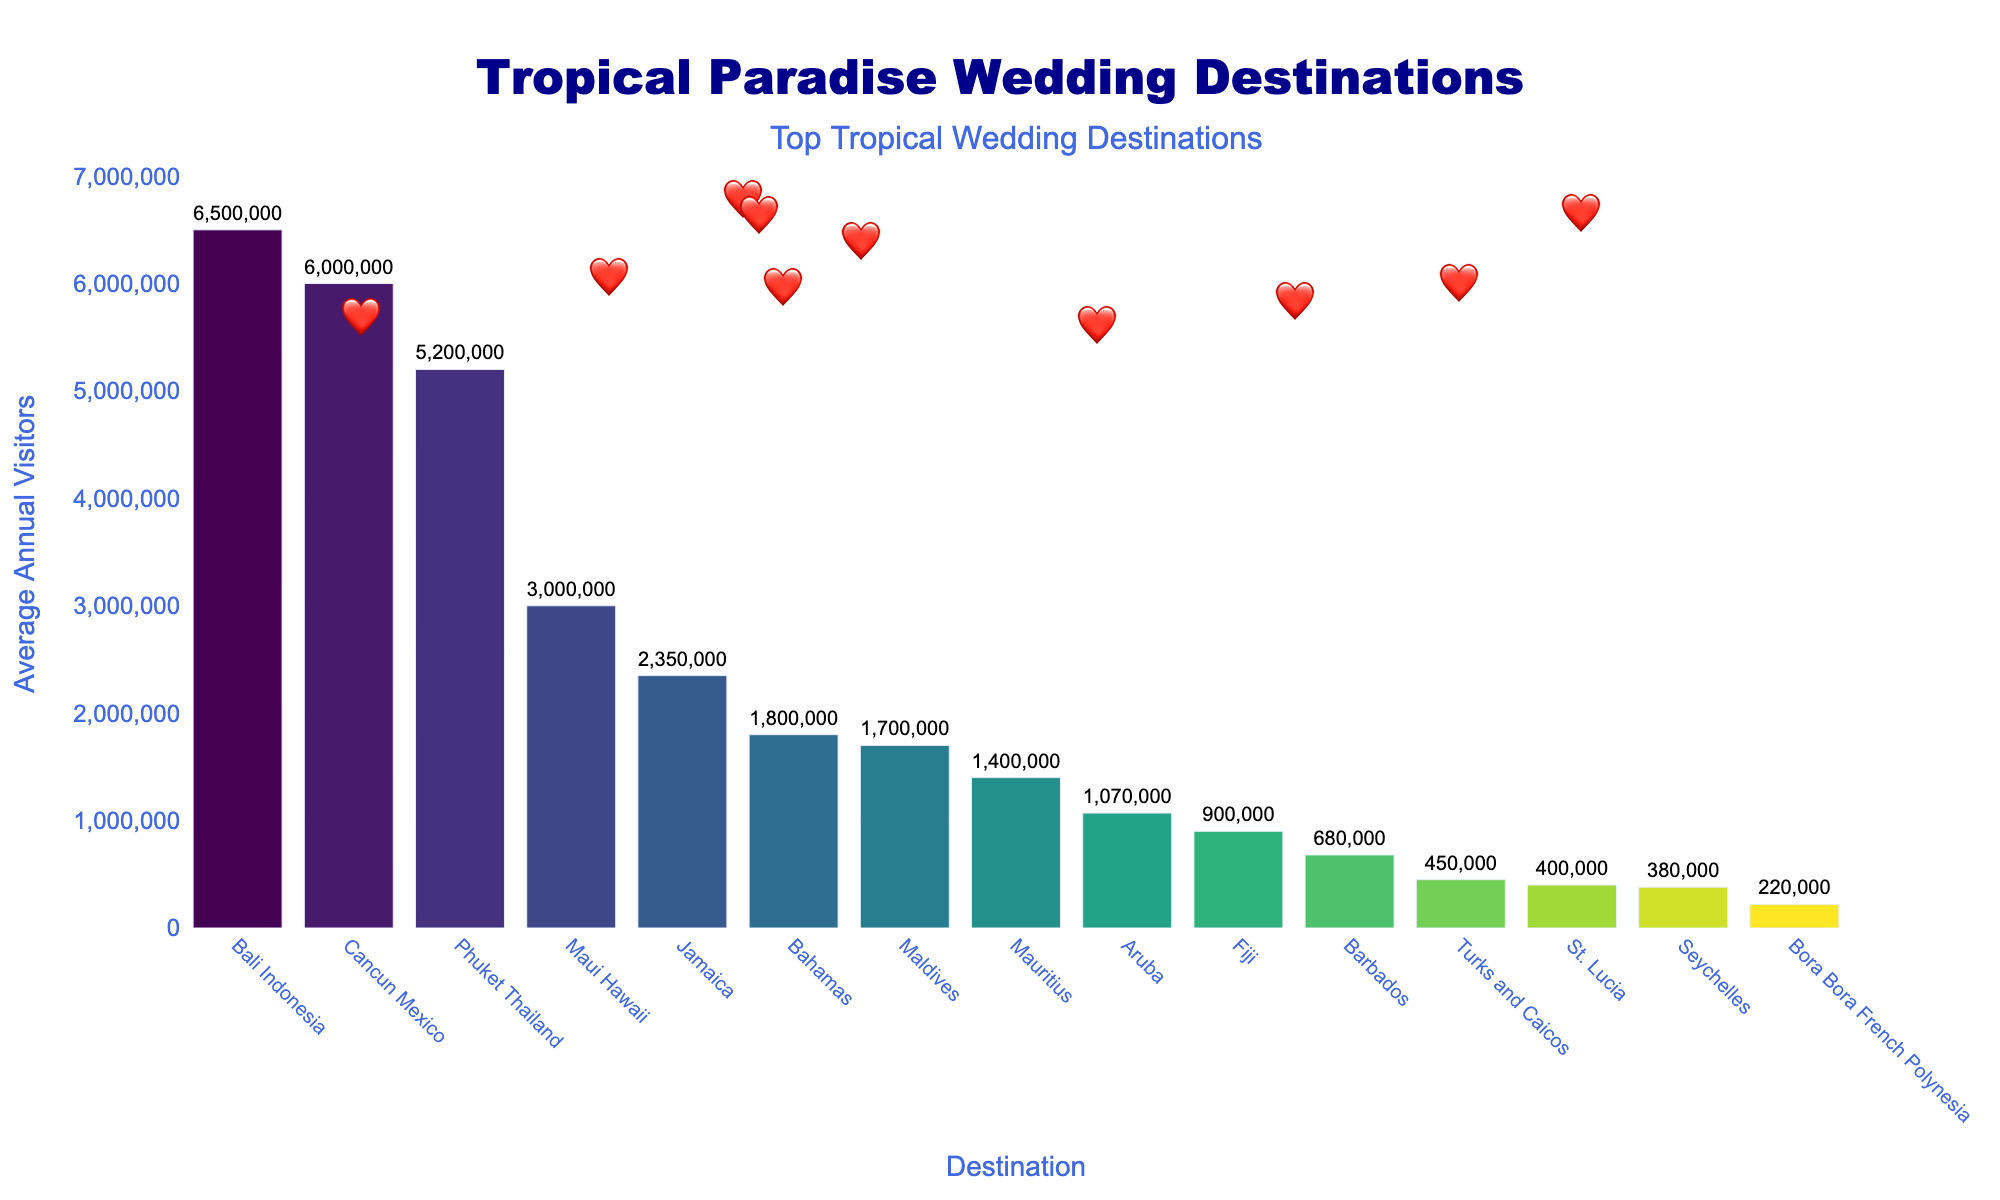what's the most popular tropical wedding destination based on the average annual visitors? The height of the first bar in the chart is highest among all, signifying it has the most visitors. The destination name, Bali Indonesia, can be read from the figure.
Answer: Bali Indonesia which destination comes second in terms of popularity? The second tallest bar on the chart indicates the second most popular destination. The name, Phuket Thailand, is written below this bar.
Answer: Phuket Thailand how many visitors do the top three destinations have combined? The top three destinations are Bali Indonesia (6,500,000), Phuket Thailand (5,200,000), and Cancun Mexico (6,000,000). Adding these numbers together: 6,500,000 + 5,200,000 + 6,000,000 = 17,700,000.
Answer: 17,700,000 which destination has approximately half the number of visitors compared to Bali Indonesia? Bali Indonesia has 6,500,000 visitors. Half of this is 3,250,000. The bar closest in height to this figure corresponds to Maui Hawaii with 3,000,000 visitors.
Answer: Maui Hawaii which two destinations have the closest number of visitors? The bars for Bahamas and Maldives seem very close in height. Bahamas has 1,800,000 visitors and Maldives has 1,700,000 visitors. The difference is only 100,000.
Answer: Bahamas and Maldives what is the least popular tropical wedding destination in the chart? The shortest bar on the chart represents the least popular destination. This bar represents Bora Bora French Polynesia with 220,000 visitors.
Answer: Bora Bora French Polynesia how many visitors does Jamaica receive annually compared to Aruba? Mexico has 2,350,000 visitors, and Aruba has 1,070,000 visitors. The difference is calculated as: 2,350,000 - 1,070,000 = 1,280,000.
Answer: 1,280,000 more visitors than Aruba if we combine the visitors of Seychelles and St. Lucia, does it exceed Maldives? Seychelles has 380,000 visitors, and St. Lucia has 400,000 visitors. Combined, they have 380,000 + 400,000 = 780,000 visitors, which is less than the Maldives' 1,700,000.
Answer: No how many destinations have more than 1 million visitors annually? Looking at the bars, destinations exceeding 1 million visitors are Bali Indonesia, Phuket Thailand, Maui Hawaii, Cancun Mexico, Jamaica, Bahamas, and Aruba. Counting these gives us 7 destinations.
Answer: 7 